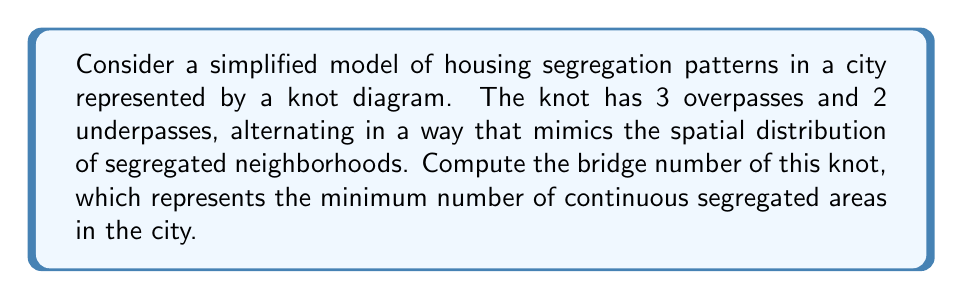Solve this math problem. To compute the bridge number of the knot representing housing segregation patterns, we'll follow these steps:

1. Understand the bridge number:
   The bridge number of a knot is the minimum number of bridges (local maxima) in any diagram of the knot.

2. Analyze the given information:
   - The knot has 3 overpasses and 2 underpasses.
   - They alternate, representing segregated neighborhoods.

3. Visualize the knot:
   The knot can be imagined as a curve with 3 peaks (overpasses) and 2 valleys (underpasses).

4. Count the local maxima:
   In this representation, each overpass corresponds to a local maximum.

5. Determine the bridge number:
   The bridge number is equal to the number of overpasses, which is 3.

6. Interpret the result:
   The bridge number of 3 indicates that there are at least 3 continuous segregated areas in the city model.

7. Verify minimality:
   Given the alternating nature of the overpasses and underpasses, this representation is likely the simplest possible, ensuring that 3 is indeed the minimum number of bridges.

Thus, the bridge number of the knot modeling the housing segregation patterns is 3.
Answer: 3 